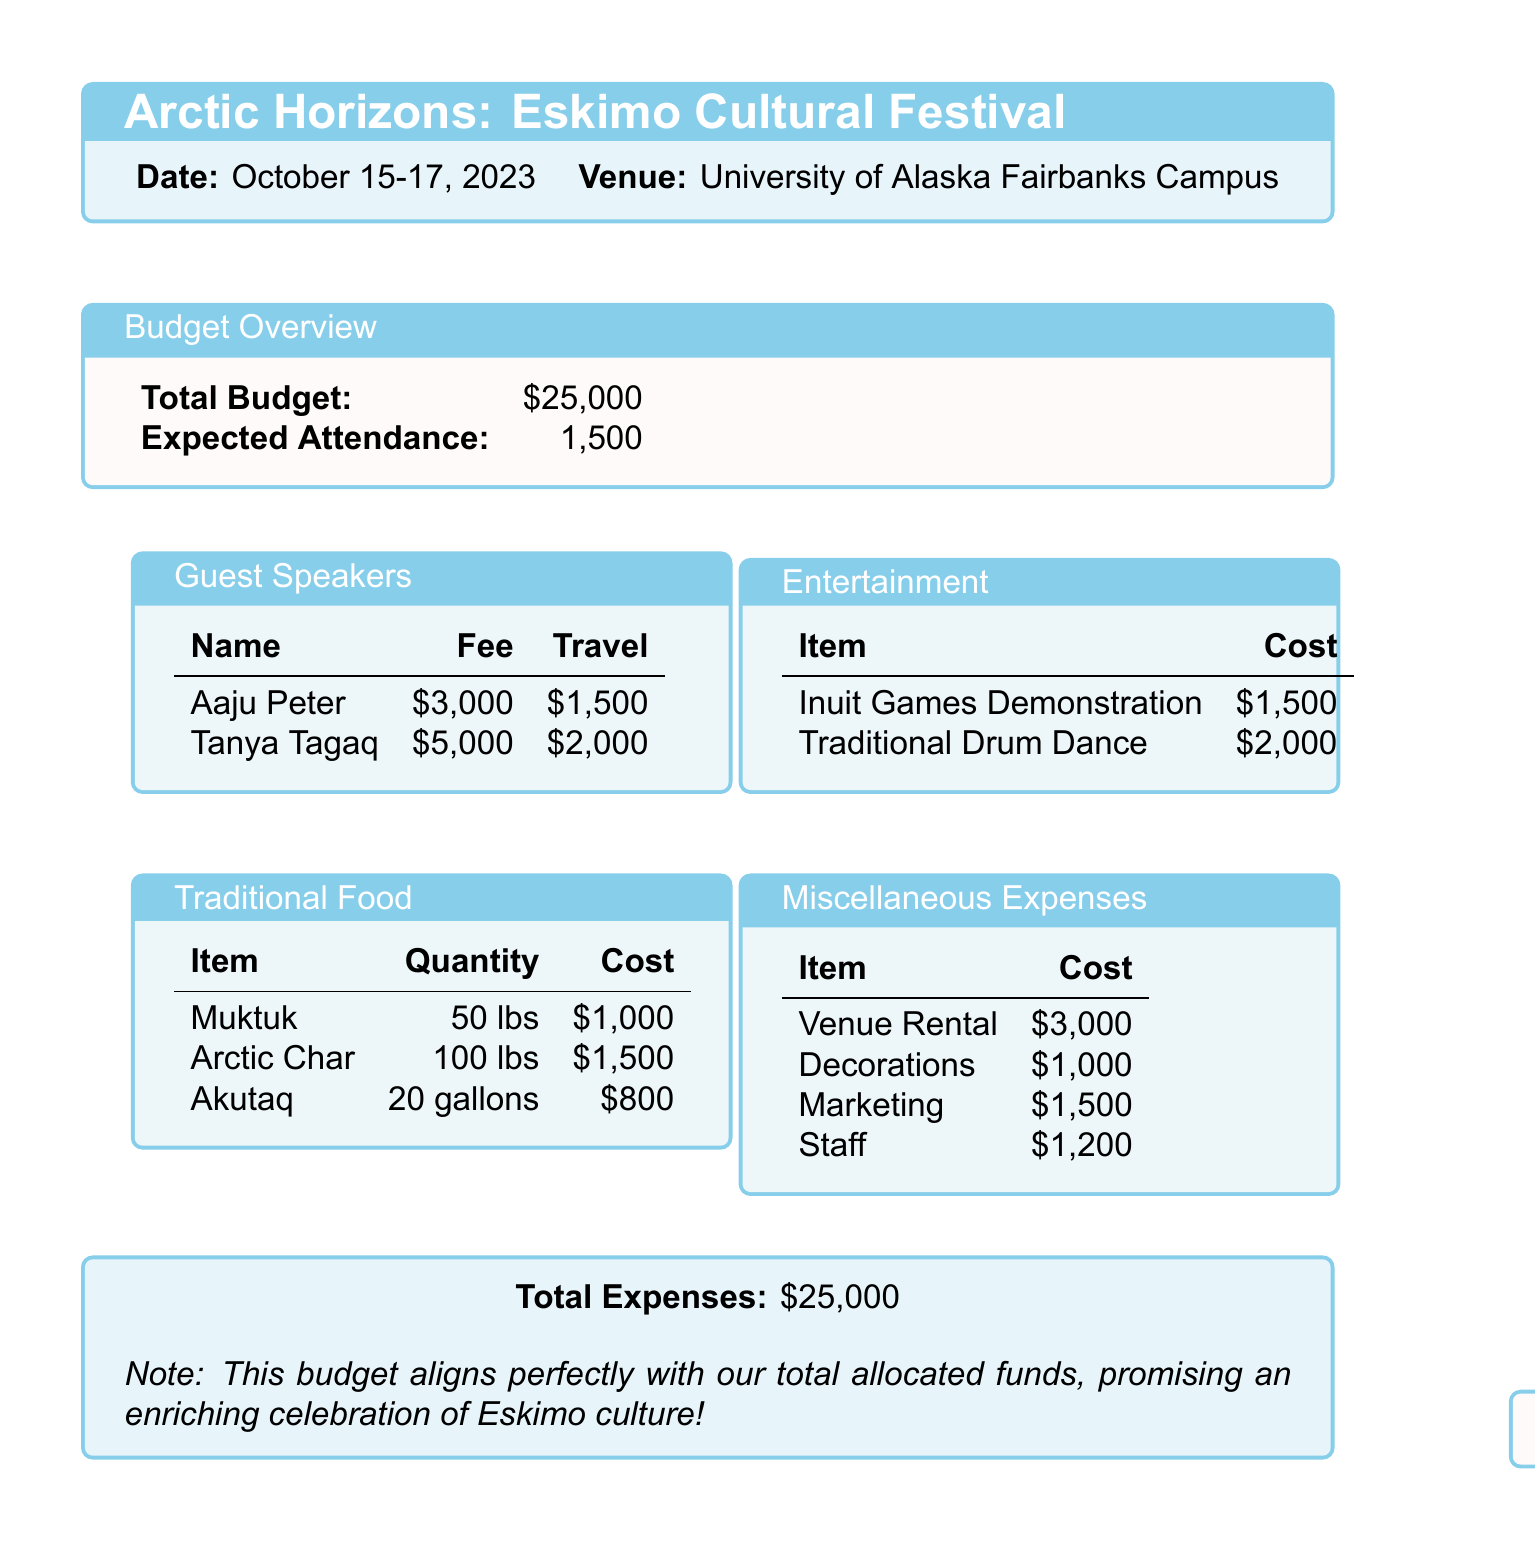what is the name of the event? The event is titled "Arctic Horizons: Eskimo Cultural Festival."
Answer: Arctic Horizons: Eskimo Cultural Festival when is the event taking place? The event is scheduled for October 15-17, 2023.
Answer: October 15-17, 2023 how much is the total budget allocated for the festival? The total budget for hosting the festival is detailed in the document.
Answer: $25,000 what is the fee for Tanya Tagaq? The fee for the guest speaker Tanya Tagaq is listed in the budget.
Answer: $5,000 how many pounds of Arctic Char will be served? The quantity of Arctic Char, a traditional food item, is specified in the document.
Answer: 100 lbs what is the total cost for the venue rental? The document includes a section detailing miscellaneous expenses, including venue rental.
Answer: $3,000 what is the total cost for entertainment? The entertainment costs are listed separately, which helps to calculate the total entertainment expenses.
Answer: $3,500 which traditional food item is served in gallons? The document specifies that Akutaq (Eskimo Ice Cream) is measured in gallons.
Answer: 20 gallons how many guest speakers are included in the budget? The number of guest speakers is indicated in the guest speakers section of the document.
Answer: 2 